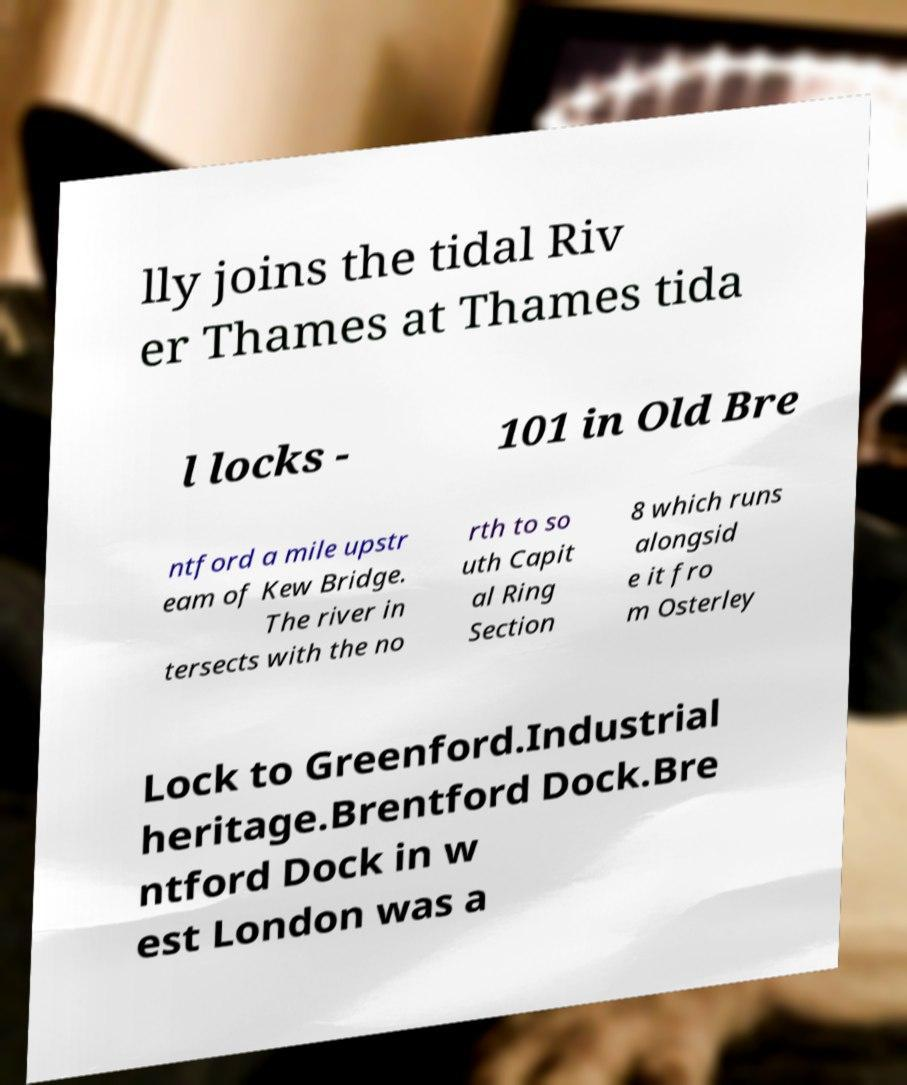Could you extract and type out the text from this image? lly joins the tidal Riv er Thames at Thames tida l locks - 101 in Old Bre ntford a mile upstr eam of Kew Bridge. The river in tersects with the no rth to so uth Capit al Ring Section 8 which runs alongsid e it fro m Osterley Lock to Greenford.Industrial heritage.Brentford Dock.Bre ntford Dock in w est London was a 